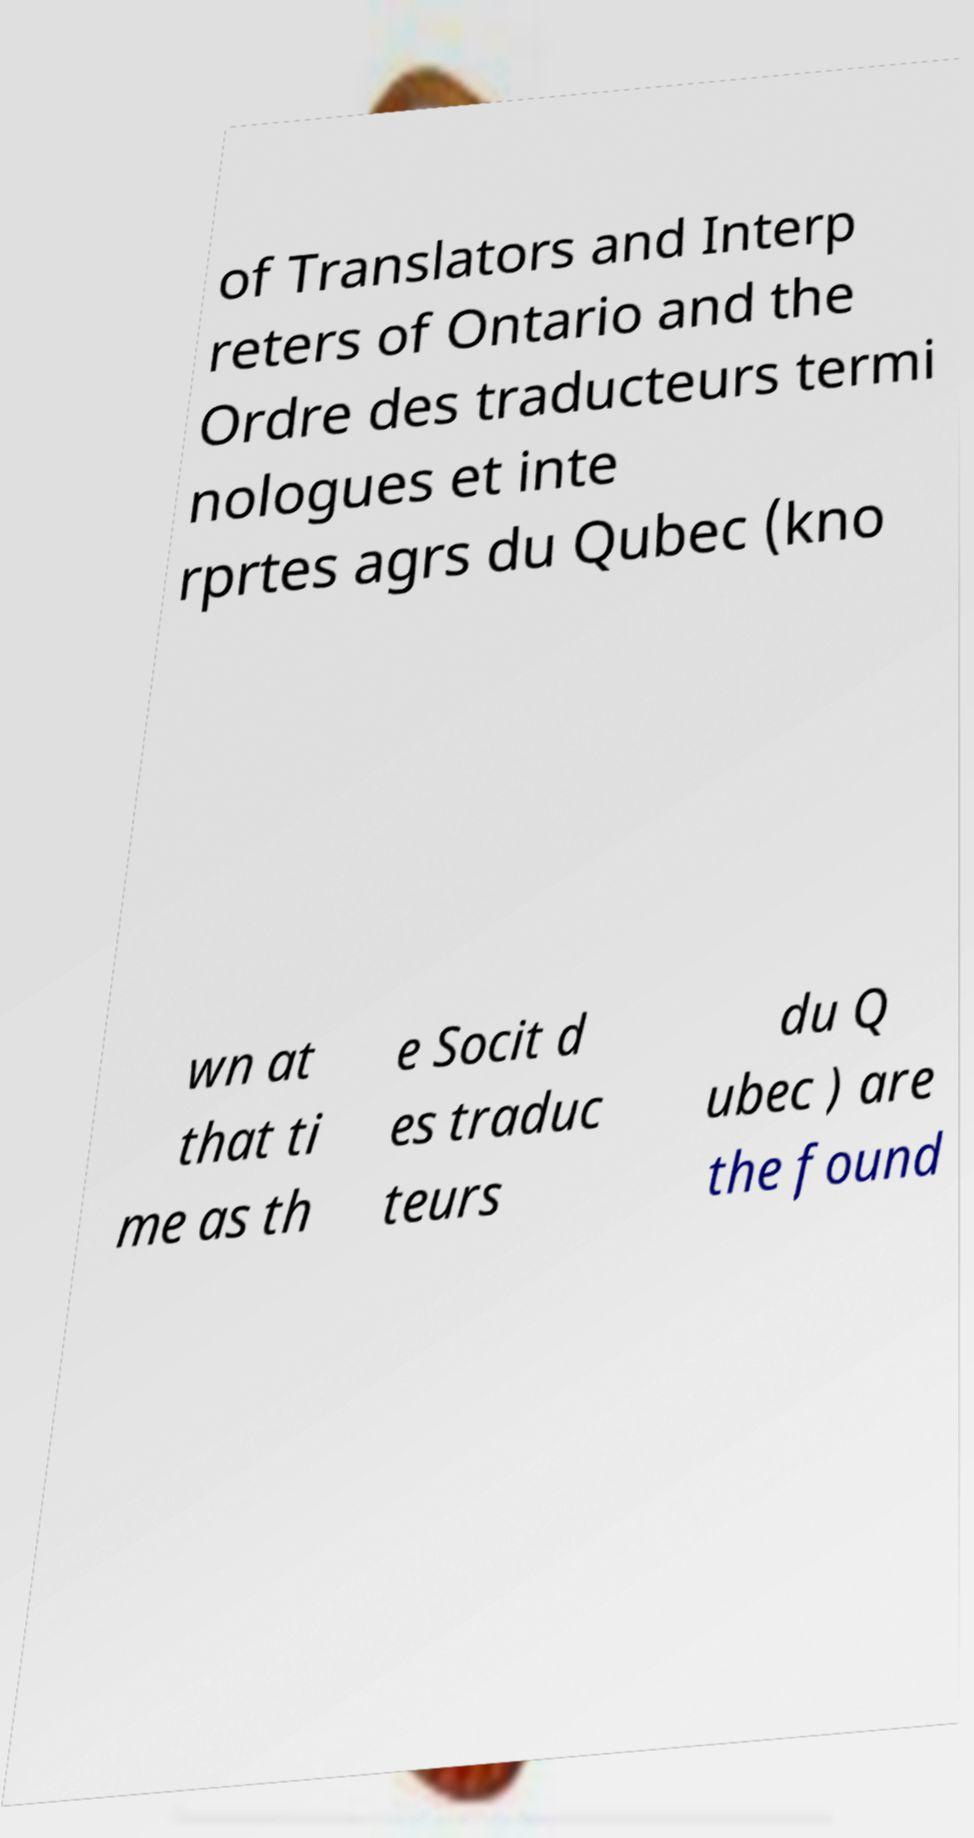I need the written content from this picture converted into text. Can you do that? of Translators and Interp reters of Ontario and the Ordre des traducteurs termi nologues et inte rprtes agrs du Qubec (kno wn at that ti me as th e Socit d es traduc teurs du Q ubec ) are the found 